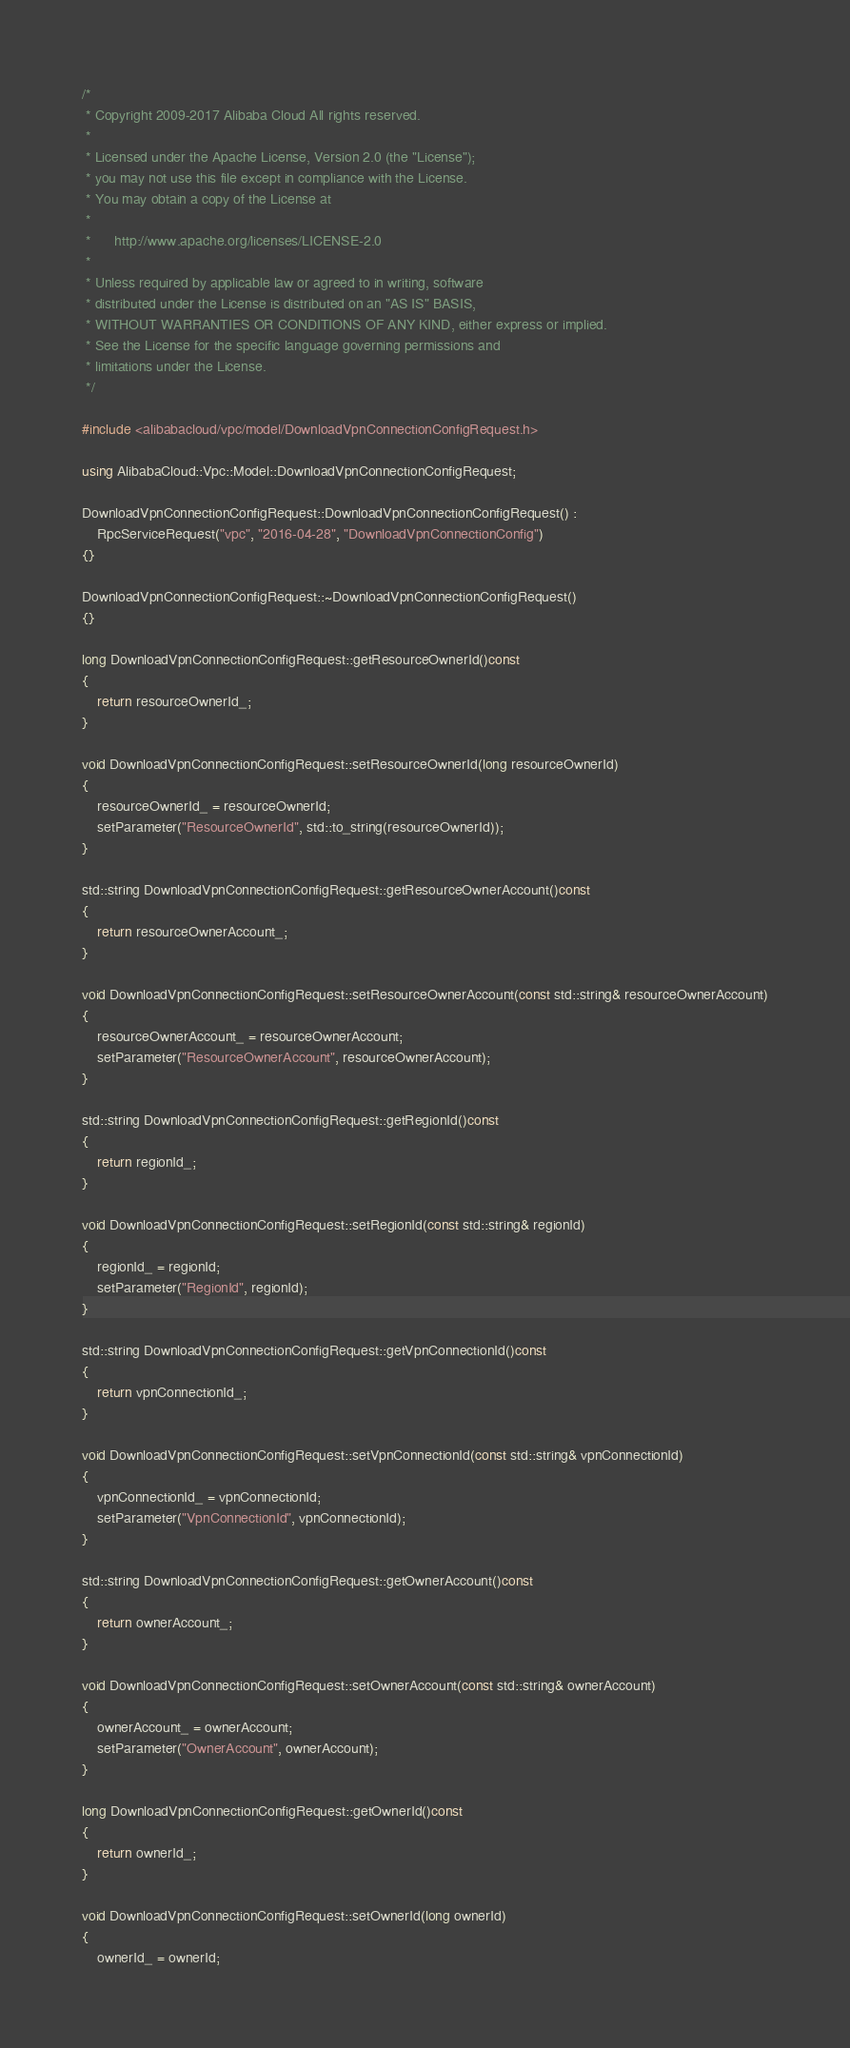Convert code to text. <code><loc_0><loc_0><loc_500><loc_500><_C++_>/*
 * Copyright 2009-2017 Alibaba Cloud All rights reserved.
 * 
 * Licensed under the Apache License, Version 2.0 (the "License");
 * you may not use this file except in compliance with the License.
 * You may obtain a copy of the License at
 * 
 *      http://www.apache.org/licenses/LICENSE-2.0
 * 
 * Unless required by applicable law or agreed to in writing, software
 * distributed under the License is distributed on an "AS IS" BASIS,
 * WITHOUT WARRANTIES OR CONDITIONS OF ANY KIND, either express or implied.
 * See the License for the specific language governing permissions and
 * limitations under the License.
 */

#include <alibabacloud/vpc/model/DownloadVpnConnectionConfigRequest.h>

using AlibabaCloud::Vpc::Model::DownloadVpnConnectionConfigRequest;

DownloadVpnConnectionConfigRequest::DownloadVpnConnectionConfigRequest() :
	RpcServiceRequest("vpc", "2016-04-28", "DownloadVpnConnectionConfig")
{}

DownloadVpnConnectionConfigRequest::~DownloadVpnConnectionConfigRequest()
{}

long DownloadVpnConnectionConfigRequest::getResourceOwnerId()const
{
	return resourceOwnerId_;
}

void DownloadVpnConnectionConfigRequest::setResourceOwnerId(long resourceOwnerId)
{
	resourceOwnerId_ = resourceOwnerId;
	setParameter("ResourceOwnerId", std::to_string(resourceOwnerId));
}

std::string DownloadVpnConnectionConfigRequest::getResourceOwnerAccount()const
{
	return resourceOwnerAccount_;
}

void DownloadVpnConnectionConfigRequest::setResourceOwnerAccount(const std::string& resourceOwnerAccount)
{
	resourceOwnerAccount_ = resourceOwnerAccount;
	setParameter("ResourceOwnerAccount", resourceOwnerAccount);
}

std::string DownloadVpnConnectionConfigRequest::getRegionId()const
{
	return regionId_;
}

void DownloadVpnConnectionConfigRequest::setRegionId(const std::string& regionId)
{
	regionId_ = regionId;
	setParameter("RegionId", regionId);
}

std::string DownloadVpnConnectionConfigRequest::getVpnConnectionId()const
{
	return vpnConnectionId_;
}

void DownloadVpnConnectionConfigRequest::setVpnConnectionId(const std::string& vpnConnectionId)
{
	vpnConnectionId_ = vpnConnectionId;
	setParameter("VpnConnectionId", vpnConnectionId);
}

std::string DownloadVpnConnectionConfigRequest::getOwnerAccount()const
{
	return ownerAccount_;
}

void DownloadVpnConnectionConfigRequest::setOwnerAccount(const std::string& ownerAccount)
{
	ownerAccount_ = ownerAccount;
	setParameter("OwnerAccount", ownerAccount);
}

long DownloadVpnConnectionConfigRequest::getOwnerId()const
{
	return ownerId_;
}

void DownloadVpnConnectionConfigRequest::setOwnerId(long ownerId)
{
	ownerId_ = ownerId;</code> 